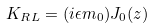<formula> <loc_0><loc_0><loc_500><loc_500>K _ { R L } = ( i \epsilon m _ { 0 } ) J _ { 0 } ( z )</formula> 